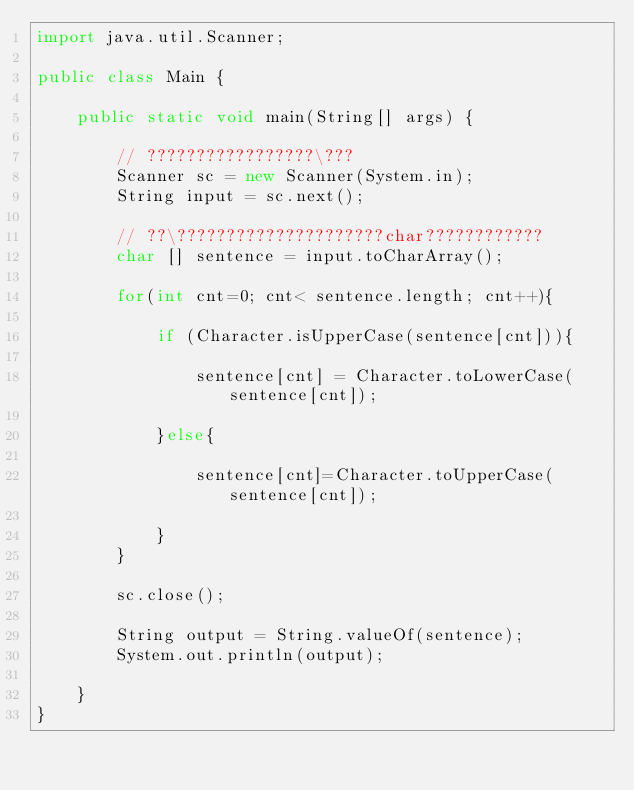Convert code to text. <code><loc_0><loc_0><loc_500><loc_500><_Java_>import java.util.Scanner;

public class Main {

	public static void main(String[] args) {

		// ?????????????????\???
		Scanner sc = new Scanner(System.in);
		String input = sc.next();

		// ??\?????????????????????char????????????
		char [] sentence = input.toCharArray();

		for(int cnt=0; cnt< sentence.length; cnt++){

			if (Character.isUpperCase(sentence[cnt])){

				sentence[cnt] = Character.toLowerCase(sentence[cnt]);

			}else{

				sentence[cnt]=Character.toUpperCase(sentence[cnt]);

			}
		}

		sc.close();

		String output = String.valueOf(sentence);
		System.out.println(output);

	}
}</code> 